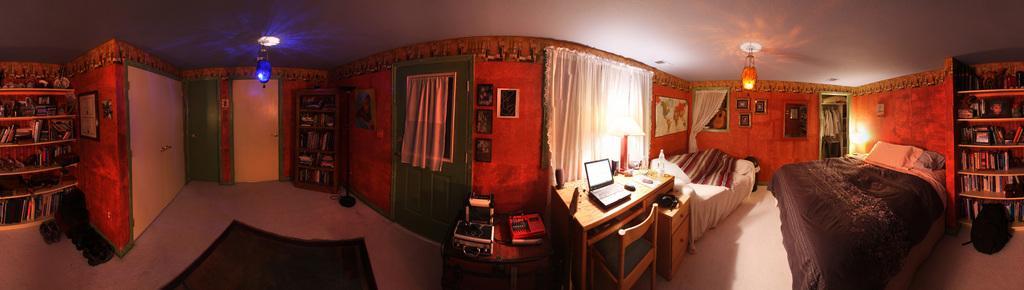How would you summarize this image in a sentence or two? In this image I can see few beds, blankets, pillows, doors, book racks, cupboard, chair, white curtains and few frames attached to the wall. I can see the laptop, bottle few objects on the tables. At the top I can see few lights and ceiling. 